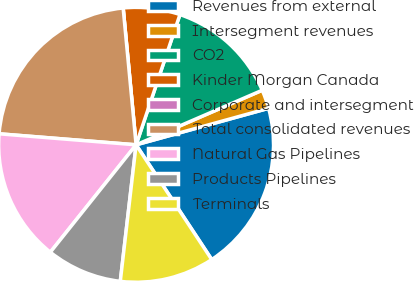Convert chart. <chart><loc_0><loc_0><loc_500><loc_500><pie_chart><fcel>Revenues from external<fcel>Intersegment revenues<fcel>CO2<fcel>Kinder Morgan Canada<fcel>Corporate and intersegment<fcel>Total consolidated revenues<fcel>Natural Gas Pipelines<fcel>Products Pipelines<fcel>Terminals<nl><fcel>20.0%<fcel>2.22%<fcel>13.33%<fcel>6.67%<fcel>0.0%<fcel>22.22%<fcel>15.55%<fcel>8.89%<fcel>11.11%<nl></chart> 